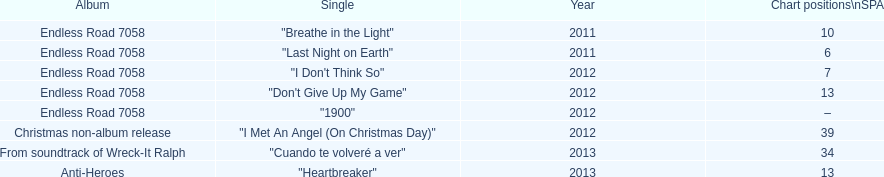Based on sales figures, what auryn album is the most popular? Endless Road 7058. 